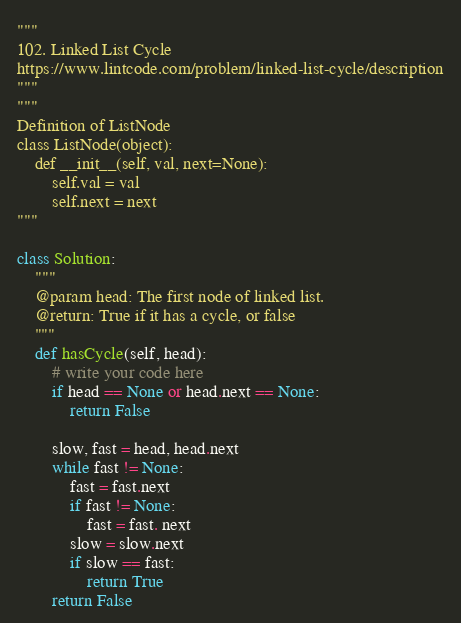Convert code to text. <code><loc_0><loc_0><loc_500><loc_500><_Python_>"""
102. Linked List Cycle
https://www.lintcode.com/problem/linked-list-cycle/description
"""
"""
Definition of ListNode
class ListNode(object):
    def __init__(self, val, next=None):
        self.val = val
        self.next = next
"""

class Solution:
    """
    @param head: The first node of linked list.
    @return: True if it has a cycle, or false
    """
    def hasCycle(self, head):
        # write your code here
        if head == None or head.next == None:
            return False

        slow, fast = head, head.next
        while fast != None:
            fast = fast.next
            if fast != None:
                fast = fast. next
            slow = slow.next
            if slow == fast:
                return True
        return False
</code> 